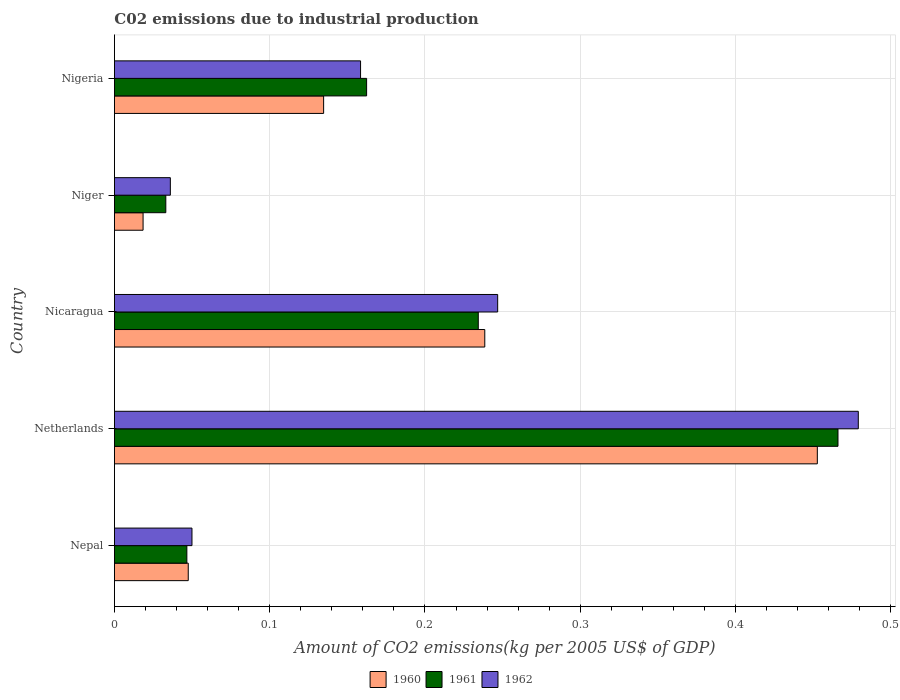How many groups of bars are there?
Give a very brief answer. 5. Are the number of bars per tick equal to the number of legend labels?
Keep it short and to the point. Yes. Are the number of bars on each tick of the Y-axis equal?
Offer a terse response. Yes. How many bars are there on the 3rd tick from the top?
Offer a terse response. 3. How many bars are there on the 2nd tick from the bottom?
Ensure brevity in your answer.  3. What is the label of the 3rd group of bars from the top?
Your answer should be very brief. Nicaragua. In how many cases, is the number of bars for a given country not equal to the number of legend labels?
Your answer should be compact. 0. What is the amount of CO2 emitted due to industrial production in 1962 in Nepal?
Offer a very short reply. 0.05. Across all countries, what is the maximum amount of CO2 emitted due to industrial production in 1962?
Offer a very short reply. 0.48. Across all countries, what is the minimum amount of CO2 emitted due to industrial production in 1961?
Provide a short and direct response. 0.03. In which country was the amount of CO2 emitted due to industrial production in 1962 maximum?
Offer a very short reply. Netherlands. In which country was the amount of CO2 emitted due to industrial production in 1960 minimum?
Provide a succinct answer. Niger. What is the total amount of CO2 emitted due to industrial production in 1960 in the graph?
Make the answer very short. 0.89. What is the difference between the amount of CO2 emitted due to industrial production in 1961 in Netherlands and that in Niger?
Make the answer very short. 0.43. What is the difference between the amount of CO2 emitted due to industrial production in 1960 in Netherlands and the amount of CO2 emitted due to industrial production in 1962 in Nicaragua?
Give a very brief answer. 0.21. What is the average amount of CO2 emitted due to industrial production in 1961 per country?
Your answer should be very brief. 0.19. What is the difference between the amount of CO2 emitted due to industrial production in 1962 and amount of CO2 emitted due to industrial production in 1960 in Nicaragua?
Your answer should be very brief. 0.01. What is the ratio of the amount of CO2 emitted due to industrial production in 1961 in Nicaragua to that in Niger?
Your answer should be compact. 7.08. Is the amount of CO2 emitted due to industrial production in 1962 in Nicaragua less than that in Niger?
Ensure brevity in your answer.  No. Is the difference between the amount of CO2 emitted due to industrial production in 1962 in Nicaragua and Nigeria greater than the difference between the amount of CO2 emitted due to industrial production in 1960 in Nicaragua and Nigeria?
Keep it short and to the point. No. What is the difference between the highest and the second highest amount of CO2 emitted due to industrial production in 1962?
Keep it short and to the point. 0.23. What is the difference between the highest and the lowest amount of CO2 emitted due to industrial production in 1960?
Provide a succinct answer. 0.43. In how many countries, is the amount of CO2 emitted due to industrial production in 1962 greater than the average amount of CO2 emitted due to industrial production in 1962 taken over all countries?
Give a very brief answer. 2. Is the sum of the amount of CO2 emitted due to industrial production in 1962 in Nepal and Netherlands greater than the maximum amount of CO2 emitted due to industrial production in 1961 across all countries?
Ensure brevity in your answer.  Yes. What does the 2nd bar from the top in Nicaragua represents?
Offer a very short reply. 1961. Is it the case that in every country, the sum of the amount of CO2 emitted due to industrial production in 1961 and amount of CO2 emitted due to industrial production in 1962 is greater than the amount of CO2 emitted due to industrial production in 1960?
Provide a succinct answer. Yes. Are all the bars in the graph horizontal?
Make the answer very short. Yes. Does the graph contain any zero values?
Keep it short and to the point. No. Where does the legend appear in the graph?
Your answer should be compact. Bottom center. How many legend labels are there?
Ensure brevity in your answer.  3. How are the legend labels stacked?
Offer a terse response. Horizontal. What is the title of the graph?
Give a very brief answer. C02 emissions due to industrial production. Does "1994" appear as one of the legend labels in the graph?
Provide a succinct answer. No. What is the label or title of the X-axis?
Offer a very short reply. Amount of CO2 emissions(kg per 2005 US$ of GDP). What is the label or title of the Y-axis?
Your answer should be very brief. Country. What is the Amount of CO2 emissions(kg per 2005 US$ of GDP) in 1960 in Nepal?
Ensure brevity in your answer.  0.05. What is the Amount of CO2 emissions(kg per 2005 US$ of GDP) in 1961 in Nepal?
Make the answer very short. 0.05. What is the Amount of CO2 emissions(kg per 2005 US$ of GDP) of 1962 in Nepal?
Provide a short and direct response. 0.05. What is the Amount of CO2 emissions(kg per 2005 US$ of GDP) of 1960 in Netherlands?
Give a very brief answer. 0.45. What is the Amount of CO2 emissions(kg per 2005 US$ of GDP) in 1961 in Netherlands?
Provide a short and direct response. 0.47. What is the Amount of CO2 emissions(kg per 2005 US$ of GDP) in 1962 in Netherlands?
Provide a short and direct response. 0.48. What is the Amount of CO2 emissions(kg per 2005 US$ of GDP) in 1960 in Nicaragua?
Give a very brief answer. 0.24. What is the Amount of CO2 emissions(kg per 2005 US$ of GDP) in 1961 in Nicaragua?
Give a very brief answer. 0.23. What is the Amount of CO2 emissions(kg per 2005 US$ of GDP) of 1962 in Nicaragua?
Offer a very short reply. 0.25. What is the Amount of CO2 emissions(kg per 2005 US$ of GDP) in 1960 in Niger?
Give a very brief answer. 0.02. What is the Amount of CO2 emissions(kg per 2005 US$ of GDP) of 1961 in Niger?
Offer a very short reply. 0.03. What is the Amount of CO2 emissions(kg per 2005 US$ of GDP) in 1962 in Niger?
Provide a succinct answer. 0.04. What is the Amount of CO2 emissions(kg per 2005 US$ of GDP) in 1960 in Nigeria?
Your response must be concise. 0.13. What is the Amount of CO2 emissions(kg per 2005 US$ of GDP) of 1961 in Nigeria?
Keep it short and to the point. 0.16. What is the Amount of CO2 emissions(kg per 2005 US$ of GDP) of 1962 in Nigeria?
Your response must be concise. 0.16. Across all countries, what is the maximum Amount of CO2 emissions(kg per 2005 US$ of GDP) in 1960?
Make the answer very short. 0.45. Across all countries, what is the maximum Amount of CO2 emissions(kg per 2005 US$ of GDP) of 1961?
Provide a short and direct response. 0.47. Across all countries, what is the maximum Amount of CO2 emissions(kg per 2005 US$ of GDP) in 1962?
Your response must be concise. 0.48. Across all countries, what is the minimum Amount of CO2 emissions(kg per 2005 US$ of GDP) of 1960?
Ensure brevity in your answer.  0.02. Across all countries, what is the minimum Amount of CO2 emissions(kg per 2005 US$ of GDP) of 1961?
Provide a short and direct response. 0.03. Across all countries, what is the minimum Amount of CO2 emissions(kg per 2005 US$ of GDP) in 1962?
Your answer should be compact. 0.04. What is the total Amount of CO2 emissions(kg per 2005 US$ of GDP) of 1960 in the graph?
Provide a short and direct response. 0.89. What is the total Amount of CO2 emissions(kg per 2005 US$ of GDP) of 1961 in the graph?
Make the answer very short. 0.94. What is the total Amount of CO2 emissions(kg per 2005 US$ of GDP) in 1962 in the graph?
Offer a terse response. 0.97. What is the difference between the Amount of CO2 emissions(kg per 2005 US$ of GDP) of 1960 in Nepal and that in Netherlands?
Provide a succinct answer. -0.41. What is the difference between the Amount of CO2 emissions(kg per 2005 US$ of GDP) in 1961 in Nepal and that in Netherlands?
Provide a short and direct response. -0.42. What is the difference between the Amount of CO2 emissions(kg per 2005 US$ of GDP) of 1962 in Nepal and that in Netherlands?
Your answer should be compact. -0.43. What is the difference between the Amount of CO2 emissions(kg per 2005 US$ of GDP) in 1960 in Nepal and that in Nicaragua?
Ensure brevity in your answer.  -0.19. What is the difference between the Amount of CO2 emissions(kg per 2005 US$ of GDP) in 1961 in Nepal and that in Nicaragua?
Your answer should be very brief. -0.19. What is the difference between the Amount of CO2 emissions(kg per 2005 US$ of GDP) of 1962 in Nepal and that in Nicaragua?
Provide a short and direct response. -0.2. What is the difference between the Amount of CO2 emissions(kg per 2005 US$ of GDP) of 1960 in Nepal and that in Niger?
Provide a succinct answer. 0.03. What is the difference between the Amount of CO2 emissions(kg per 2005 US$ of GDP) of 1961 in Nepal and that in Niger?
Offer a very short reply. 0.01. What is the difference between the Amount of CO2 emissions(kg per 2005 US$ of GDP) in 1962 in Nepal and that in Niger?
Give a very brief answer. 0.01. What is the difference between the Amount of CO2 emissions(kg per 2005 US$ of GDP) in 1960 in Nepal and that in Nigeria?
Your answer should be compact. -0.09. What is the difference between the Amount of CO2 emissions(kg per 2005 US$ of GDP) in 1961 in Nepal and that in Nigeria?
Your answer should be compact. -0.12. What is the difference between the Amount of CO2 emissions(kg per 2005 US$ of GDP) of 1962 in Nepal and that in Nigeria?
Make the answer very short. -0.11. What is the difference between the Amount of CO2 emissions(kg per 2005 US$ of GDP) of 1960 in Netherlands and that in Nicaragua?
Give a very brief answer. 0.21. What is the difference between the Amount of CO2 emissions(kg per 2005 US$ of GDP) in 1961 in Netherlands and that in Nicaragua?
Offer a very short reply. 0.23. What is the difference between the Amount of CO2 emissions(kg per 2005 US$ of GDP) in 1962 in Netherlands and that in Nicaragua?
Your answer should be very brief. 0.23. What is the difference between the Amount of CO2 emissions(kg per 2005 US$ of GDP) of 1960 in Netherlands and that in Niger?
Your response must be concise. 0.43. What is the difference between the Amount of CO2 emissions(kg per 2005 US$ of GDP) of 1961 in Netherlands and that in Niger?
Offer a very short reply. 0.43. What is the difference between the Amount of CO2 emissions(kg per 2005 US$ of GDP) of 1962 in Netherlands and that in Niger?
Your response must be concise. 0.44. What is the difference between the Amount of CO2 emissions(kg per 2005 US$ of GDP) of 1960 in Netherlands and that in Nigeria?
Offer a very short reply. 0.32. What is the difference between the Amount of CO2 emissions(kg per 2005 US$ of GDP) in 1961 in Netherlands and that in Nigeria?
Offer a very short reply. 0.3. What is the difference between the Amount of CO2 emissions(kg per 2005 US$ of GDP) of 1962 in Netherlands and that in Nigeria?
Offer a terse response. 0.32. What is the difference between the Amount of CO2 emissions(kg per 2005 US$ of GDP) of 1960 in Nicaragua and that in Niger?
Your response must be concise. 0.22. What is the difference between the Amount of CO2 emissions(kg per 2005 US$ of GDP) in 1961 in Nicaragua and that in Niger?
Your answer should be very brief. 0.2. What is the difference between the Amount of CO2 emissions(kg per 2005 US$ of GDP) of 1962 in Nicaragua and that in Niger?
Keep it short and to the point. 0.21. What is the difference between the Amount of CO2 emissions(kg per 2005 US$ of GDP) of 1960 in Nicaragua and that in Nigeria?
Make the answer very short. 0.1. What is the difference between the Amount of CO2 emissions(kg per 2005 US$ of GDP) in 1961 in Nicaragua and that in Nigeria?
Provide a short and direct response. 0.07. What is the difference between the Amount of CO2 emissions(kg per 2005 US$ of GDP) of 1962 in Nicaragua and that in Nigeria?
Give a very brief answer. 0.09. What is the difference between the Amount of CO2 emissions(kg per 2005 US$ of GDP) of 1960 in Niger and that in Nigeria?
Your answer should be compact. -0.12. What is the difference between the Amount of CO2 emissions(kg per 2005 US$ of GDP) of 1961 in Niger and that in Nigeria?
Your answer should be compact. -0.13. What is the difference between the Amount of CO2 emissions(kg per 2005 US$ of GDP) of 1962 in Niger and that in Nigeria?
Your answer should be compact. -0.12. What is the difference between the Amount of CO2 emissions(kg per 2005 US$ of GDP) in 1960 in Nepal and the Amount of CO2 emissions(kg per 2005 US$ of GDP) in 1961 in Netherlands?
Your answer should be compact. -0.42. What is the difference between the Amount of CO2 emissions(kg per 2005 US$ of GDP) in 1960 in Nepal and the Amount of CO2 emissions(kg per 2005 US$ of GDP) in 1962 in Netherlands?
Offer a terse response. -0.43. What is the difference between the Amount of CO2 emissions(kg per 2005 US$ of GDP) in 1961 in Nepal and the Amount of CO2 emissions(kg per 2005 US$ of GDP) in 1962 in Netherlands?
Your answer should be very brief. -0.43. What is the difference between the Amount of CO2 emissions(kg per 2005 US$ of GDP) of 1960 in Nepal and the Amount of CO2 emissions(kg per 2005 US$ of GDP) of 1961 in Nicaragua?
Provide a succinct answer. -0.19. What is the difference between the Amount of CO2 emissions(kg per 2005 US$ of GDP) of 1960 in Nepal and the Amount of CO2 emissions(kg per 2005 US$ of GDP) of 1962 in Nicaragua?
Make the answer very short. -0.2. What is the difference between the Amount of CO2 emissions(kg per 2005 US$ of GDP) in 1961 in Nepal and the Amount of CO2 emissions(kg per 2005 US$ of GDP) in 1962 in Nicaragua?
Keep it short and to the point. -0.2. What is the difference between the Amount of CO2 emissions(kg per 2005 US$ of GDP) in 1960 in Nepal and the Amount of CO2 emissions(kg per 2005 US$ of GDP) in 1961 in Niger?
Offer a very short reply. 0.01. What is the difference between the Amount of CO2 emissions(kg per 2005 US$ of GDP) in 1960 in Nepal and the Amount of CO2 emissions(kg per 2005 US$ of GDP) in 1962 in Niger?
Ensure brevity in your answer.  0.01. What is the difference between the Amount of CO2 emissions(kg per 2005 US$ of GDP) in 1961 in Nepal and the Amount of CO2 emissions(kg per 2005 US$ of GDP) in 1962 in Niger?
Your answer should be compact. 0.01. What is the difference between the Amount of CO2 emissions(kg per 2005 US$ of GDP) in 1960 in Nepal and the Amount of CO2 emissions(kg per 2005 US$ of GDP) in 1961 in Nigeria?
Keep it short and to the point. -0.11. What is the difference between the Amount of CO2 emissions(kg per 2005 US$ of GDP) of 1960 in Nepal and the Amount of CO2 emissions(kg per 2005 US$ of GDP) of 1962 in Nigeria?
Provide a succinct answer. -0.11. What is the difference between the Amount of CO2 emissions(kg per 2005 US$ of GDP) of 1961 in Nepal and the Amount of CO2 emissions(kg per 2005 US$ of GDP) of 1962 in Nigeria?
Provide a short and direct response. -0.11. What is the difference between the Amount of CO2 emissions(kg per 2005 US$ of GDP) in 1960 in Netherlands and the Amount of CO2 emissions(kg per 2005 US$ of GDP) in 1961 in Nicaragua?
Offer a terse response. 0.22. What is the difference between the Amount of CO2 emissions(kg per 2005 US$ of GDP) in 1960 in Netherlands and the Amount of CO2 emissions(kg per 2005 US$ of GDP) in 1962 in Nicaragua?
Your answer should be compact. 0.21. What is the difference between the Amount of CO2 emissions(kg per 2005 US$ of GDP) in 1961 in Netherlands and the Amount of CO2 emissions(kg per 2005 US$ of GDP) in 1962 in Nicaragua?
Your answer should be compact. 0.22. What is the difference between the Amount of CO2 emissions(kg per 2005 US$ of GDP) of 1960 in Netherlands and the Amount of CO2 emissions(kg per 2005 US$ of GDP) of 1961 in Niger?
Your answer should be compact. 0.42. What is the difference between the Amount of CO2 emissions(kg per 2005 US$ of GDP) in 1960 in Netherlands and the Amount of CO2 emissions(kg per 2005 US$ of GDP) in 1962 in Niger?
Provide a short and direct response. 0.42. What is the difference between the Amount of CO2 emissions(kg per 2005 US$ of GDP) of 1961 in Netherlands and the Amount of CO2 emissions(kg per 2005 US$ of GDP) of 1962 in Niger?
Give a very brief answer. 0.43. What is the difference between the Amount of CO2 emissions(kg per 2005 US$ of GDP) of 1960 in Netherlands and the Amount of CO2 emissions(kg per 2005 US$ of GDP) of 1961 in Nigeria?
Ensure brevity in your answer.  0.29. What is the difference between the Amount of CO2 emissions(kg per 2005 US$ of GDP) in 1960 in Netherlands and the Amount of CO2 emissions(kg per 2005 US$ of GDP) in 1962 in Nigeria?
Offer a terse response. 0.29. What is the difference between the Amount of CO2 emissions(kg per 2005 US$ of GDP) of 1961 in Netherlands and the Amount of CO2 emissions(kg per 2005 US$ of GDP) of 1962 in Nigeria?
Your response must be concise. 0.31. What is the difference between the Amount of CO2 emissions(kg per 2005 US$ of GDP) of 1960 in Nicaragua and the Amount of CO2 emissions(kg per 2005 US$ of GDP) of 1961 in Niger?
Your answer should be very brief. 0.21. What is the difference between the Amount of CO2 emissions(kg per 2005 US$ of GDP) in 1960 in Nicaragua and the Amount of CO2 emissions(kg per 2005 US$ of GDP) in 1962 in Niger?
Offer a terse response. 0.2. What is the difference between the Amount of CO2 emissions(kg per 2005 US$ of GDP) in 1961 in Nicaragua and the Amount of CO2 emissions(kg per 2005 US$ of GDP) in 1962 in Niger?
Make the answer very short. 0.2. What is the difference between the Amount of CO2 emissions(kg per 2005 US$ of GDP) of 1960 in Nicaragua and the Amount of CO2 emissions(kg per 2005 US$ of GDP) of 1961 in Nigeria?
Ensure brevity in your answer.  0.08. What is the difference between the Amount of CO2 emissions(kg per 2005 US$ of GDP) of 1960 in Nicaragua and the Amount of CO2 emissions(kg per 2005 US$ of GDP) of 1962 in Nigeria?
Make the answer very short. 0.08. What is the difference between the Amount of CO2 emissions(kg per 2005 US$ of GDP) in 1961 in Nicaragua and the Amount of CO2 emissions(kg per 2005 US$ of GDP) in 1962 in Nigeria?
Your answer should be compact. 0.08. What is the difference between the Amount of CO2 emissions(kg per 2005 US$ of GDP) in 1960 in Niger and the Amount of CO2 emissions(kg per 2005 US$ of GDP) in 1961 in Nigeria?
Ensure brevity in your answer.  -0.14. What is the difference between the Amount of CO2 emissions(kg per 2005 US$ of GDP) in 1960 in Niger and the Amount of CO2 emissions(kg per 2005 US$ of GDP) in 1962 in Nigeria?
Provide a short and direct response. -0.14. What is the difference between the Amount of CO2 emissions(kg per 2005 US$ of GDP) of 1961 in Niger and the Amount of CO2 emissions(kg per 2005 US$ of GDP) of 1962 in Nigeria?
Your answer should be very brief. -0.13. What is the average Amount of CO2 emissions(kg per 2005 US$ of GDP) in 1960 per country?
Offer a very short reply. 0.18. What is the average Amount of CO2 emissions(kg per 2005 US$ of GDP) of 1961 per country?
Give a very brief answer. 0.19. What is the average Amount of CO2 emissions(kg per 2005 US$ of GDP) of 1962 per country?
Your answer should be compact. 0.19. What is the difference between the Amount of CO2 emissions(kg per 2005 US$ of GDP) of 1960 and Amount of CO2 emissions(kg per 2005 US$ of GDP) of 1961 in Nepal?
Your answer should be compact. 0. What is the difference between the Amount of CO2 emissions(kg per 2005 US$ of GDP) of 1960 and Amount of CO2 emissions(kg per 2005 US$ of GDP) of 1962 in Nepal?
Ensure brevity in your answer.  -0. What is the difference between the Amount of CO2 emissions(kg per 2005 US$ of GDP) of 1961 and Amount of CO2 emissions(kg per 2005 US$ of GDP) of 1962 in Nepal?
Provide a short and direct response. -0. What is the difference between the Amount of CO2 emissions(kg per 2005 US$ of GDP) of 1960 and Amount of CO2 emissions(kg per 2005 US$ of GDP) of 1961 in Netherlands?
Your answer should be compact. -0.01. What is the difference between the Amount of CO2 emissions(kg per 2005 US$ of GDP) in 1960 and Amount of CO2 emissions(kg per 2005 US$ of GDP) in 1962 in Netherlands?
Provide a succinct answer. -0.03. What is the difference between the Amount of CO2 emissions(kg per 2005 US$ of GDP) in 1961 and Amount of CO2 emissions(kg per 2005 US$ of GDP) in 1962 in Netherlands?
Your answer should be very brief. -0.01. What is the difference between the Amount of CO2 emissions(kg per 2005 US$ of GDP) of 1960 and Amount of CO2 emissions(kg per 2005 US$ of GDP) of 1961 in Nicaragua?
Your answer should be very brief. 0. What is the difference between the Amount of CO2 emissions(kg per 2005 US$ of GDP) in 1960 and Amount of CO2 emissions(kg per 2005 US$ of GDP) in 1962 in Nicaragua?
Your answer should be very brief. -0.01. What is the difference between the Amount of CO2 emissions(kg per 2005 US$ of GDP) of 1961 and Amount of CO2 emissions(kg per 2005 US$ of GDP) of 1962 in Nicaragua?
Your answer should be compact. -0.01. What is the difference between the Amount of CO2 emissions(kg per 2005 US$ of GDP) in 1960 and Amount of CO2 emissions(kg per 2005 US$ of GDP) in 1961 in Niger?
Provide a short and direct response. -0.01. What is the difference between the Amount of CO2 emissions(kg per 2005 US$ of GDP) of 1960 and Amount of CO2 emissions(kg per 2005 US$ of GDP) of 1962 in Niger?
Offer a very short reply. -0.02. What is the difference between the Amount of CO2 emissions(kg per 2005 US$ of GDP) in 1961 and Amount of CO2 emissions(kg per 2005 US$ of GDP) in 1962 in Niger?
Provide a short and direct response. -0. What is the difference between the Amount of CO2 emissions(kg per 2005 US$ of GDP) of 1960 and Amount of CO2 emissions(kg per 2005 US$ of GDP) of 1961 in Nigeria?
Offer a very short reply. -0.03. What is the difference between the Amount of CO2 emissions(kg per 2005 US$ of GDP) in 1960 and Amount of CO2 emissions(kg per 2005 US$ of GDP) in 1962 in Nigeria?
Keep it short and to the point. -0.02. What is the difference between the Amount of CO2 emissions(kg per 2005 US$ of GDP) of 1961 and Amount of CO2 emissions(kg per 2005 US$ of GDP) of 1962 in Nigeria?
Offer a terse response. 0. What is the ratio of the Amount of CO2 emissions(kg per 2005 US$ of GDP) of 1960 in Nepal to that in Netherlands?
Make the answer very short. 0.1. What is the ratio of the Amount of CO2 emissions(kg per 2005 US$ of GDP) in 1961 in Nepal to that in Netherlands?
Offer a very short reply. 0.1. What is the ratio of the Amount of CO2 emissions(kg per 2005 US$ of GDP) of 1962 in Nepal to that in Netherlands?
Provide a succinct answer. 0.1. What is the ratio of the Amount of CO2 emissions(kg per 2005 US$ of GDP) in 1960 in Nepal to that in Nicaragua?
Give a very brief answer. 0.2. What is the ratio of the Amount of CO2 emissions(kg per 2005 US$ of GDP) of 1961 in Nepal to that in Nicaragua?
Give a very brief answer. 0.2. What is the ratio of the Amount of CO2 emissions(kg per 2005 US$ of GDP) in 1962 in Nepal to that in Nicaragua?
Keep it short and to the point. 0.2. What is the ratio of the Amount of CO2 emissions(kg per 2005 US$ of GDP) in 1960 in Nepal to that in Niger?
Give a very brief answer. 2.58. What is the ratio of the Amount of CO2 emissions(kg per 2005 US$ of GDP) of 1961 in Nepal to that in Niger?
Give a very brief answer. 1.41. What is the ratio of the Amount of CO2 emissions(kg per 2005 US$ of GDP) of 1962 in Nepal to that in Niger?
Make the answer very short. 1.39. What is the ratio of the Amount of CO2 emissions(kg per 2005 US$ of GDP) of 1960 in Nepal to that in Nigeria?
Make the answer very short. 0.35. What is the ratio of the Amount of CO2 emissions(kg per 2005 US$ of GDP) in 1961 in Nepal to that in Nigeria?
Your answer should be compact. 0.29. What is the ratio of the Amount of CO2 emissions(kg per 2005 US$ of GDP) in 1962 in Nepal to that in Nigeria?
Your answer should be very brief. 0.32. What is the ratio of the Amount of CO2 emissions(kg per 2005 US$ of GDP) in 1960 in Netherlands to that in Nicaragua?
Offer a terse response. 1.9. What is the ratio of the Amount of CO2 emissions(kg per 2005 US$ of GDP) in 1961 in Netherlands to that in Nicaragua?
Provide a short and direct response. 1.99. What is the ratio of the Amount of CO2 emissions(kg per 2005 US$ of GDP) in 1962 in Netherlands to that in Nicaragua?
Provide a succinct answer. 1.94. What is the ratio of the Amount of CO2 emissions(kg per 2005 US$ of GDP) in 1960 in Netherlands to that in Niger?
Provide a short and direct response. 24.53. What is the ratio of the Amount of CO2 emissions(kg per 2005 US$ of GDP) in 1961 in Netherlands to that in Niger?
Offer a very short reply. 14.08. What is the ratio of the Amount of CO2 emissions(kg per 2005 US$ of GDP) of 1962 in Netherlands to that in Niger?
Offer a very short reply. 13.3. What is the ratio of the Amount of CO2 emissions(kg per 2005 US$ of GDP) of 1960 in Netherlands to that in Nigeria?
Offer a very short reply. 3.36. What is the ratio of the Amount of CO2 emissions(kg per 2005 US$ of GDP) in 1961 in Netherlands to that in Nigeria?
Your answer should be very brief. 2.87. What is the ratio of the Amount of CO2 emissions(kg per 2005 US$ of GDP) of 1962 in Netherlands to that in Nigeria?
Offer a terse response. 3.02. What is the ratio of the Amount of CO2 emissions(kg per 2005 US$ of GDP) in 1960 in Nicaragua to that in Niger?
Give a very brief answer. 12.93. What is the ratio of the Amount of CO2 emissions(kg per 2005 US$ of GDP) of 1961 in Nicaragua to that in Niger?
Provide a short and direct response. 7.08. What is the ratio of the Amount of CO2 emissions(kg per 2005 US$ of GDP) in 1962 in Nicaragua to that in Niger?
Your response must be concise. 6.85. What is the ratio of the Amount of CO2 emissions(kg per 2005 US$ of GDP) of 1960 in Nicaragua to that in Nigeria?
Your answer should be compact. 1.77. What is the ratio of the Amount of CO2 emissions(kg per 2005 US$ of GDP) in 1961 in Nicaragua to that in Nigeria?
Your response must be concise. 1.44. What is the ratio of the Amount of CO2 emissions(kg per 2005 US$ of GDP) of 1962 in Nicaragua to that in Nigeria?
Provide a short and direct response. 1.56. What is the ratio of the Amount of CO2 emissions(kg per 2005 US$ of GDP) in 1960 in Niger to that in Nigeria?
Make the answer very short. 0.14. What is the ratio of the Amount of CO2 emissions(kg per 2005 US$ of GDP) of 1961 in Niger to that in Nigeria?
Provide a succinct answer. 0.2. What is the ratio of the Amount of CO2 emissions(kg per 2005 US$ of GDP) of 1962 in Niger to that in Nigeria?
Your answer should be compact. 0.23. What is the difference between the highest and the second highest Amount of CO2 emissions(kg per 2005 US$ of GDP) in 1960?
Your response must be concise. 0.21. What is the difference between the highest and the second highest Amount of CO2 emissions(kg per 2005 US$ of GDP) in 1961?
Your response must be concise. 0.23. What is the difference between the highest and the second highest Amount of CO2 emissions(kg per 2005 US$ of GDP) in 1962?
Keep it short and to the point. 0.23. What is the difference between the highest and the lowest Amount of CO2 emissions(kg per 2005 US$ of GDP) of 1960?
Offer a very short reply. 0.43. What is the difference between the highest and the lowest Amount of CO2 emissions(kg per 2005 US$ of GDP) in 1961?
Your response must be concise. 0.43. What is the difference between the highest and the lowest Amount of CO2 emissions(kg per 2005 US$ of GDP) in 1962?
Ensure brevity in your answer.  0.44. 